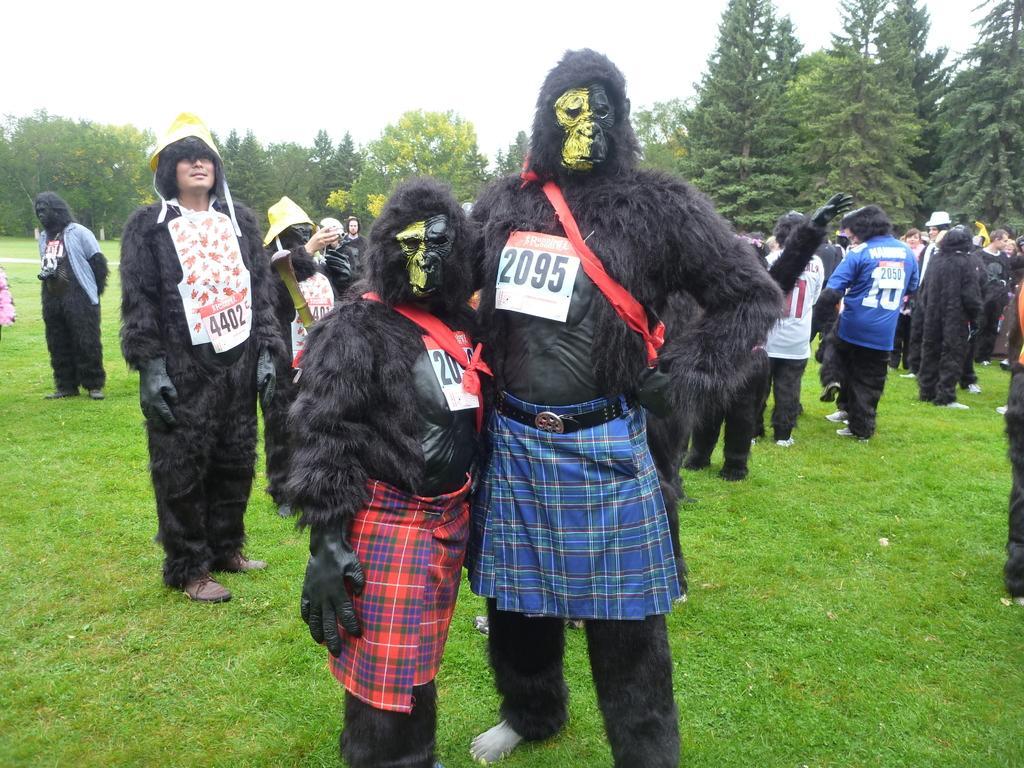In one or two sentences, can you explain what this image depicts? In the foreground of the image there are two people wearing costumes. In the background of the image there are people standing. At the bottom of the image there is grass. In the background of the image there are trees and sky. 